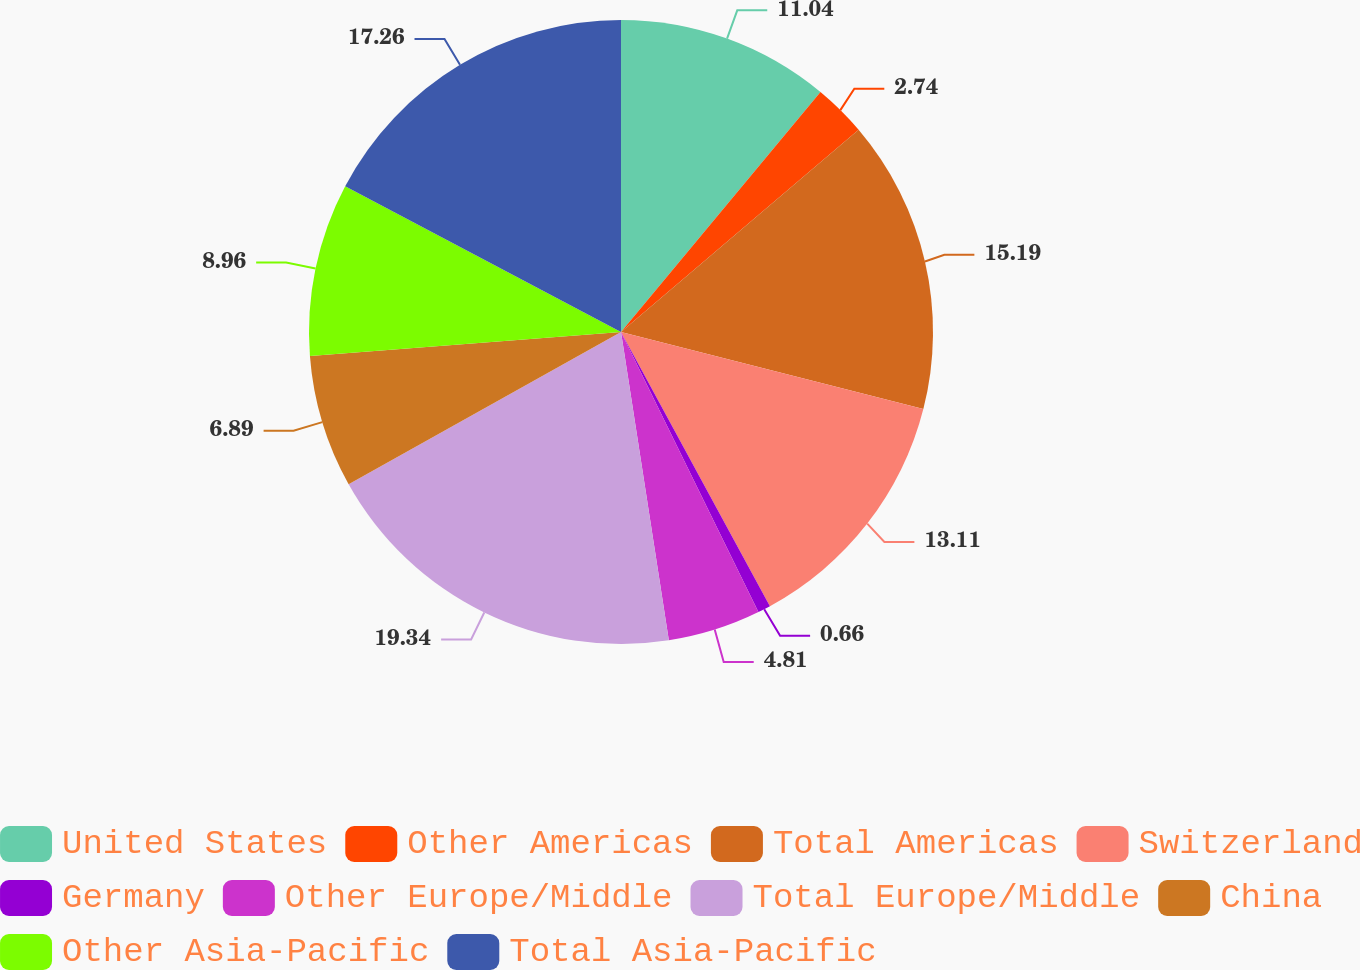<chart> <loc_0><loc_0><loc_500><loc_500><pie_chart><fcel>United States<fcel>Other Americas<fcel>Total Americas<fcel>Switzerland<fcel>Germany<fcel>Other Europe/Middle<fcel>Total Europe/Middle<fcel>China<fcel>Other Asia-Pacific<fcel>Total Asia-Pacific<nl><fcel>11.04%<fcel>2.74%<fcel>15.19%<fcel>13.11%<fcel>0.66%<fcel>4.81%<fcel>19.34%<fcel>6.89%<fcel>8.96%<fcel>17.26%<nl></chart> 